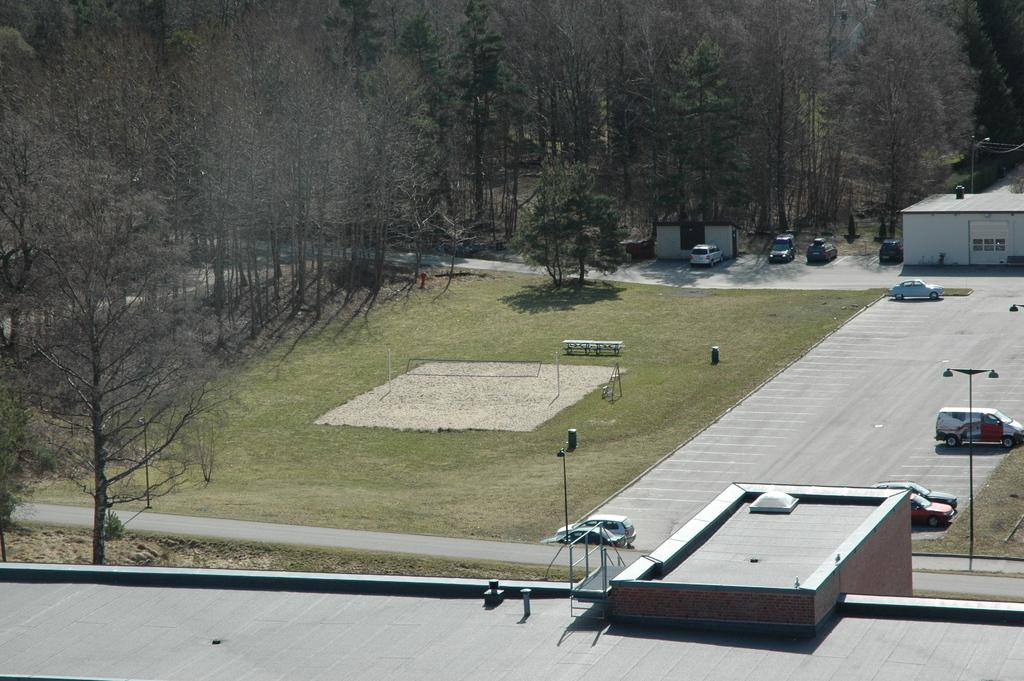What is located in the foreground of the image? There is a building in the foreground of the image. What can be seen on the left side and in the background of the image? There are trees on the left side and in the background of the image. What type of transportation can be seen in the image? There are vehicles visible in the image. How many buildings can be seen in the image? There is at least one other building in the image. What kind of path is present in the image? There is a path in the image. What material is present in the image that is typically transparent? There is glass present in the image. What type of seating is available in the image? There are benches in the image. What other objects can be seen in the image? Various objects are visible in the image. What type of sugar can be seen on the stick in the image? There is no sugar or stick present in the image. 